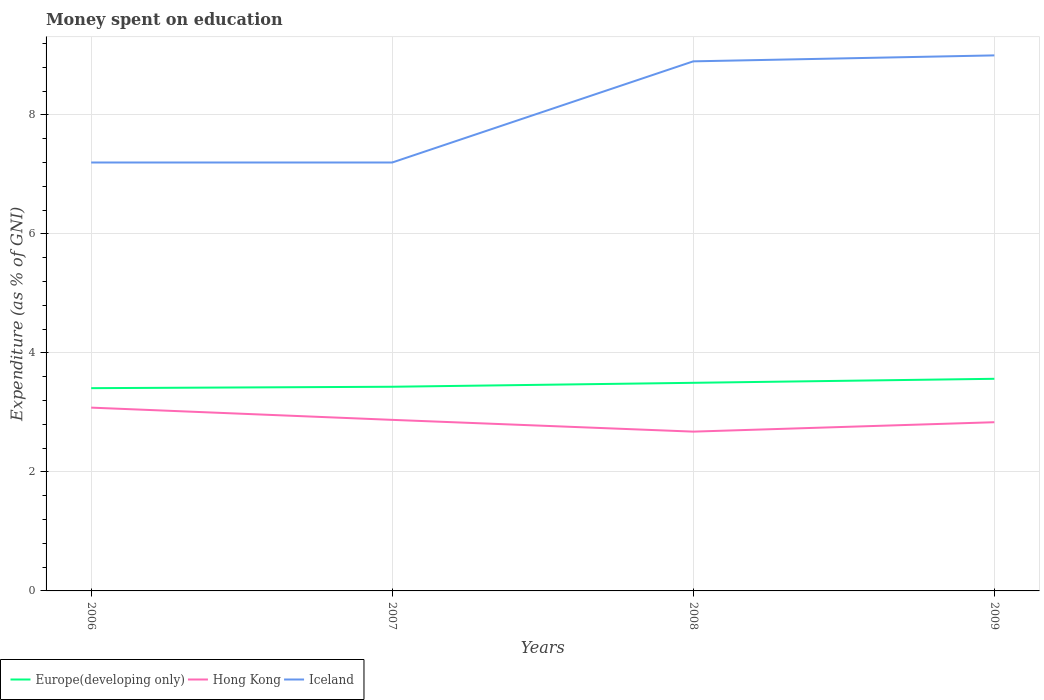How many different coloured lines are there?
Your answer should be very brief. 3. Across all years, what is the maximum amount of money spent on education in Europe(developing only)?
Make the answer very short. 3.41. In which year was the amount of money spent on education in Hong Kong maximum?
Offer a very short reply. 2008. What is the total amount of money spent on education in Hong Kong in the graph?
Make the answer very short. 0.04. What is the difference between the highest and the second highest amount of money spent on education in Iceland?
Your answer should be very brief. 1.8. Is the amount of money spent on education in Iceland strictly greater than the amount of money spent on education in Hong Kong over the years?
Your answer should be very brief. No. How many lines are there?
Your answer should be compact. 3. How many years are there in the graph?
Offer a terse response. 4. What is the difference between two consecutive major ticks on the Y-axis?
Provide a succinct answer. 2. Does the graph contain any zero values?
Give a very brief answer. No. Does the graph contain grids?
Keep it short and to the point. Yes. How many legend labels are there?
Offer a terse response. 3. How are the legend labels stacked?
Your answer should be very brief. Horizontal. What is the title of the graph?
Ensure brevity in your answer.  Money spent on education. What is the label or title of the X-axis?
Offer a very short reply. Years. What is the label or title of the Y-axis?
Provide a succinct answer. Expenditure (as % of GNI). What is the Expenditure (as % of GNI) of Europe(developing only) in 2006?
Offer a terse response. 3.41. What is the Expenditure (as % of GNI) of Hong Kong in 2006?
Your answer should be compact. 3.08. What is the Expenditure (as % of GNI) in Iceland in 2006?
Provide a short and direct response. 7.2. What is the Expenditure (as % of GNI) in Europe(developing only) in 2007?
Keep it short and to the point. 3.43. What is the Expenditure (as % of GNI) of Hong Kong in 2007?
Ensure brevity in your answer.  2.87. What is the Expenditure (as % of GNI) of Iceland in 2007?
Provide a short and direct response. 7.2. What is the Expenditure (as % of GNI) of Europe(developing only) in 2008?
Your answer should be very brief. 3.5. What is the Expenditure (as % of GNI) in Hong Kong in 2008?
Provide a succinct answer. 2.68. What is the Expenditure (as % of GNI) of Iceland in 2008?
Provide a succinct answer. 8.9. What is the Expenditure (as % of GNI) in Europe(developing only) in 2009?
Keep it short and to the point. 3.56. What is the Expenditure (as % of GNI) of Hong Kong in 2009?
Your response must be concise. 2.84. Across all years, what is the maximum Expenditure (as % of GNI) in Europe(developing only)?
Provide a succinct answer. 3.56. Across all years, what is the maximum Expenditure (as % of GNI) in Hong Kong?
Offer a terse response. 3.08. Across all years, what is the minimum Expenditure (as % of GNI) of Europe(developing only)?
Provide a short and direct response. 3.41. Across all years, what is the minimum Expenditure (as % of GNI) in Hong Kong?
Make the answer very short. 2.68. Across all years, what is the minimum Expenditure (as % of GNI) of Iceland?
Make the answer very short. 7.2. What is the total Expenditure (as % of GNI) in Europe(developing only) in the graph?
Ensure brevity in your answer.  13.9. What is the total Expenditure (as % of GNI) of Hong Kong in the graph?
Offer a terse response. 11.47. What is the total Expenditure (as % of GNI) in Iceland in the graph?
Offer a terse response. 32.3. What is the difference between the Expenditure (as % of GNI) of Europe(developing only) in 2006 and that in 2007?
Make the answer very short. -0.02. What is the difference between the Expenditure (as % of GNI) of Hong Kong in 2006 and that in 2007?
Your answer should be very brief. 0.21. What is the difference between the Expenditure (as % of GNI) in Europe(developing only) in 2006 and that in 2008?
Offer a very short reply. -0.09. What is the difference between the Expenditure (as % of GNI) in Hong Kong in 2006 and that in 2008?
Offer a very short reply. 0.4. What is the difference between the Expenditure (as % of GNI) in Iceland in 2006 and that in 2008?
Make the answer very short. -1.7. What is the difference between the Expenditure (as % of GNI) in Europe(developing only) in 2006 and that in 2009?
Keep it short and to the point. -0.16. What is the difference between the Expenditure (as % of GNI) in Hong Kong in 2006 and that in 2009?
Make the answer very short. 0.25. What is the difference between the Expenditure (as % of GNI) in Europe(developing only) in 2007 and that in 2008?
Give a very brief answer. -0.07. What is the difference between the Expenditure (as % of GNI) in Hong Kong in 2007 and that in 2008?
Keep it short and to the point. 0.2. What is the difference between the Expenditure (as % of GNI) in Europe(developing only) in 2007 and that in 2009?
Your answer should be compact. -0.13. What is the difference between the Expenditure (as % of GNI) in Hong Kong in 2007 and that in 2009?
Provide a succinct answer. 0.04. What is the difference between the Expenditure (as % of GNI) in Europe(developing only) in 2008 and that in 2009?
Offer a terse response. -0.07. What is the difference between the Expenditure (as % of GNI) of Hong Kong in 2008 and that in 2009?
Offer a very short reply. -0.16. What is the difference between the Expenditure (as % of GNI) in Europe(developing only) in 2006 and the Expenditure (as % of GNI) in Hong Kong in 2007?
Offer a terse response. 0.53. What is the difference between the Expenditure (as % of GNI) in Europe(developing only) in 2006 and the Expenditure (as % of GNI) in Iceland in 2007?
Provide a short and direct response. -3.79. What is the difference between the Expenditure (as % of GNI) in Hong Kong in 2006 and the Expenditure (as % of GNI) in Iceland in 2007?
Offer a terse response. -4.12. What is the difference between the Expenditure (as % of GNI) of Europe(developing only) in 2006 and the Expenditure (as % of GNI) of Hong Kong in 2008?
Ensure brevity in your answer.  0.73. What is the difference between the Expenditure (as % of GNI) of Europe(developing only) in 2006 and the Expenditure (as % of GNI) of Iceland in 2008?
Provide a short and direct response. -5.49. What is the difference between the Expenditure (as % of GNI) in Hong Kong in 2006 and the Expenditure (as % of GNI) in Iceland in 2008?
Make the answer very short. -5.82. What is the difference between the Expenditure (as % of GNI) of Europe(developing only) in 2006 and the Expenditure (as % of GNI) of Hong Kong in 2009?
Make the answer very short. 0.57. What is the difference between the Expenditure (as % of GNI) of Europe(developing only) in 2006 and the Expenditure (as % of GNI) of Iceland in 2009?
Your response must be concise. -5.59. What is the difference between the Expenditure (as % of GNI) in Hong Kong in 2006 and the Expenditure (as % of GNI) in Iceland in 2009?
Offer a very short reply. -5.92. What is the difference between the Expenditure (as % of GNI) of Europe(developing only) in 2007 and the Expenditure (as % of GNI) of Hong Kong in 2008?
Provide a short and direct response. 0.75. What is the difference between the Expenditure (as % of GNI) of Europe(developing only) in 2007 and the Expenditure (as % of GNI) of Iceland in 2008?
Provide a succinct answer. -5.47. What is the difference between the Expenditure (as % of GNI) in Hong Kong in 2007 and the Expenditure (as % of GNI) in Iceland in 2008?
Your response must be concise. -6.03. What is the difference between the Expenditure (as % of GNI) in Europe(developing only) in 2007 and the Expenditure (as % of GNI) in Hong Kong in 2009?
Give a very brief answer. 0.6. What is the difference between the Expenditure (as % of GNI) of Europe(developing only) in 2007 and the Expenditure (as % of GNI) of Iceland in 2009?
Your answer should be very brief. -5.57. What is the difference between the Expenditure (as % of GNI) of Hong Kong in 2007 and the Expenditure (as % of GNI) of Iceland in 2009?
Provide a succinct answer. -6.13. What is the difference between the Expenditure (as % of GNI) in Europe(developing only) in 2008 and the Expenditure (as % of GNI) in Hong Kong in 2009?
Offer a very short reply. 0.66. What is the difference between the Expenditure (as % of GNI) in Europe(developing only) in 2008 and the Expenditure (as % of GNI) in Iceland in 2009?
Offer a very short reply. -5.5. What is the difference between the Expenditure (as % of GNI) in Hong Kong in 2008 and the Expenditure (as % of GNI) in Iceland in 2009?
Give a very brief answer. -6.32. What is the average Expenditure (as % of GNI) of Europe(developing only) per year?
Provide a short and direct response. 3.48. What is the average Expenditure (as % of GNI) of Hong Kong per year?
Make the answer very short. 2.87. What is the average Expenditure (as % of GNI) in Iceland per year?
Offer a very short reply. 8.07. In the year 2006, what is the difference between the Expenditure (as % of GNI) in Europe(developing only) and Expenditure (as % of GNI) in Hong Kong?
Your answer should be compact. 0.33. In the year 2006, what is the difference between the Expenditure (as % of GNI) of Europe(developing only) and Expenditure (as % of GNI) of Iceland?
Offer a terse response. -3.79. In the year 2006, what is the difference between the Expenditure (as % of GNI) in Hong Kong and Expenditure (as % of GNI) in Iceland?
Ensure brevity in your answer.  -4.12. In the year 2007, what is the difference between the Expenditure (as % of GNI) in Europe(developing only) and Expenditure (as % of GNI) in Hong Kong?
Keep it short and to the point. 0.56. In the year 2007, what is the difference between the Expenditure (as % of GNI) of Europe(developing only) and Expenditure (as % of GNI) of Iceland?
Provide a succinct answer. -3.77. In the year 2007, what is the difference between the Expenditure (as % of GNI) in Hong Kong and Expenditure (as % of GNI) in Iceland?
Your answer should be compact. -4.33. In the year 2008, what is the difference between the Expenditure (as % of GNI) of Europe(developing only) and Expenditure (as % of GNI) of Hong Kong?
Provide a short and direct response. 0.82. In the year 2008, what is the difference between the Expenditure (as % of GNI) of Europe(developing only) and Expenditure (as % of GNI) of Iceland?
Provide a short and direct response. -5.4. In the year 2008, what is the difference between the Expenditure (as % of GNI) of Hong Kong and Expenditure (as % of GNI) of Iceland?
Your answer should be very brief. -6.22. In the year 2009, what is the difference between the Expenditure (as % of GNI) of Europe(developing only) and Expenditure (as % of GNI) of Hong Kong?
Provide a succinct answer. 0.73. In the year 2009, what is the difference between the Expenditure (as % of GNI) in Europe(developing only) and Expenditure (as % of GNI) in Iceland?
Provide a succinct answer. -5.43. In the year 2009, what is the difference between the Expenditure (as % of GNI) in Hong Kong and Expenditure (as % of GNI) in Iceland?
Keep it short and to the point. -6.16. What is the ratio of the Expenditure (as % of GNI) in Europe(developing only) in 2006 to that in 2007?
Offer a terse response. 0.99. What is the ratio of the Expenditure (as % of GNI) of Hong Kong in 2006 to that in 2007?
Provide a succinct answer. 1.07. What is the ratio of the Expenditure (as % of GNI) in Iceland in 2006 to that in 2007?
Provide a succinct answer. 1. What is the ratio of the Expenditure (as % of GNI) of Europe(developing only) in 2006 to that in 2008?
Offer a terse response. 0.97. What is the ratio of the Expenditure (as % of GNI) in Hong Kong in 2006 to that in 2008?
Provide a succinct answer. 1.15. What is the ratio of the Expenditure (as % of GNI) in Iceland in 2006 to that in 2008?
Give a very brief answer. 0.81. What is the ratio of the Expenditure (as % of GNI) of Europe(developing only) in 2006 to that in 2009?
Make the answer very short. 0.96. What is the ratio of the Expenditure (as % of GNI) of Hong Kong in 2006 to that in 2009?
Ensure brevity in your answer.  1.09. What is the ratio of the Expenditure (as % of GNI) of Iceland in 2006 to that in 2009?
Ensure brevity in your answer.  0.8. What is the ratio of the Expenditure (as % of GNI) of Europe(developing only) in 2007 to that in 2008?
Provide a short and direct response. 0.98. What is the ratio of the Expenditure (as % of GNI) in Hong Kong in 2007 to that in 2008?
Your answer should be very brief. 1.07. What is the ratio of the Expenditure (as % of GNI) of Iceland in 2007 to that in 2008?
Ensure brevity in your answer.  0.81. What is the ratio of the Expenditure (as % of GNI) of Europe(developing only) in 2007 to that in 2009?
Your response must be concise. 0.96. What is the ratio of the Expenditure (as % of GNI) in Hong Kong in 2007 to that in 2009?
Your response must be concise. 1.01. What is the ratio of the Expenditure (as % of GNI) of Europe(developing only) in 2008 to that in 2009?
Make the answer very short. 0.98. What is the ratio of the Expenditure (as % of GNI) in Hong Kong in 2008 to that in 2009?
Provide a short and direct response. 0.94. What is the ratio of the Expenditure (as % of GNI) of Iceland in 2008 to that in 2009?
Your answer should be compact. 0.99. What is the difference between the highest and the second highest Expenditure (as % of GNI) of Europe(developing only)?
Offer a terse response. 0.07. What is the difference between the highest and the second highest Expenditure (as % of GNI) of Hong Kong?
Provide a succinct answer. 0.21. What is the difference between the highest and the second highest Expenditure (as % of GNI) in Iceland?
Make the answer very short. 0.1. What is the difference between the highest and the lowest Expenditure (as % of GNI) of Europe(developing only)?
Give a very brief answer. 0.16. What is the difference between the highest and the lowest Expenditure (as % of GNI) of Hong Kong?
Make the answer very short. 0.4. 